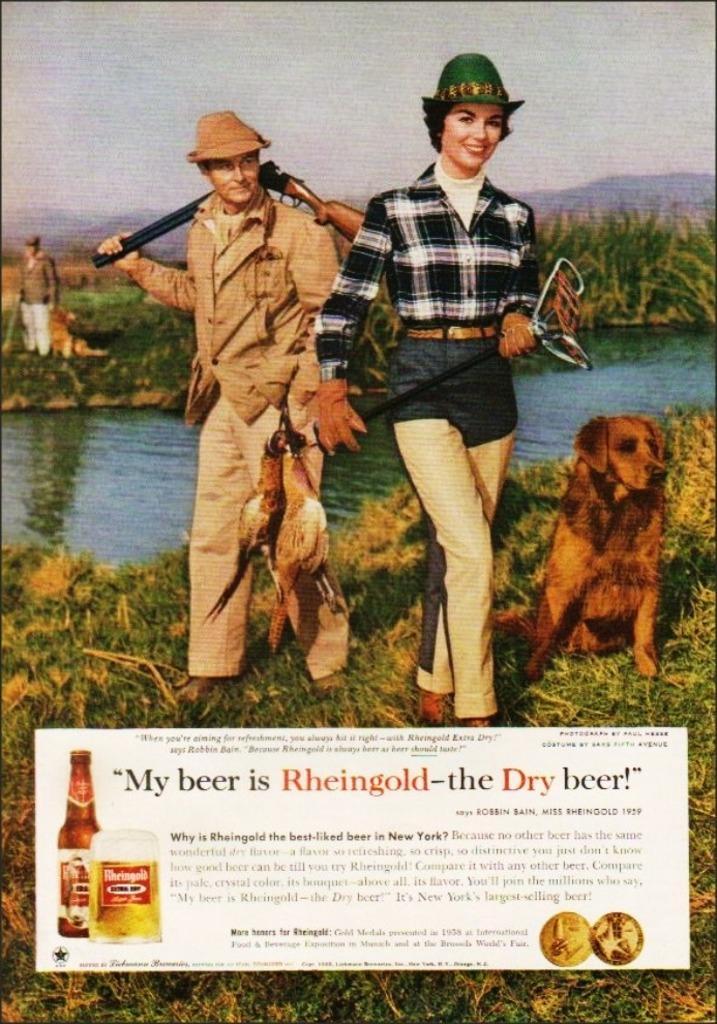Please provide a concise description of this image. In this image we can see a photo which includes text, some persons, we can see an animal and birds. And we can see water, grass, at the top we can see the sky. 